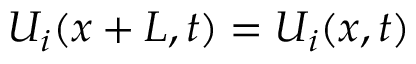Convert formula to latex. <formula><loc_0><loc_0><loc_500><loc_500>U _ { i } ( { x } + { L } , t ) = U _ { i } ( x , t )</formula> 